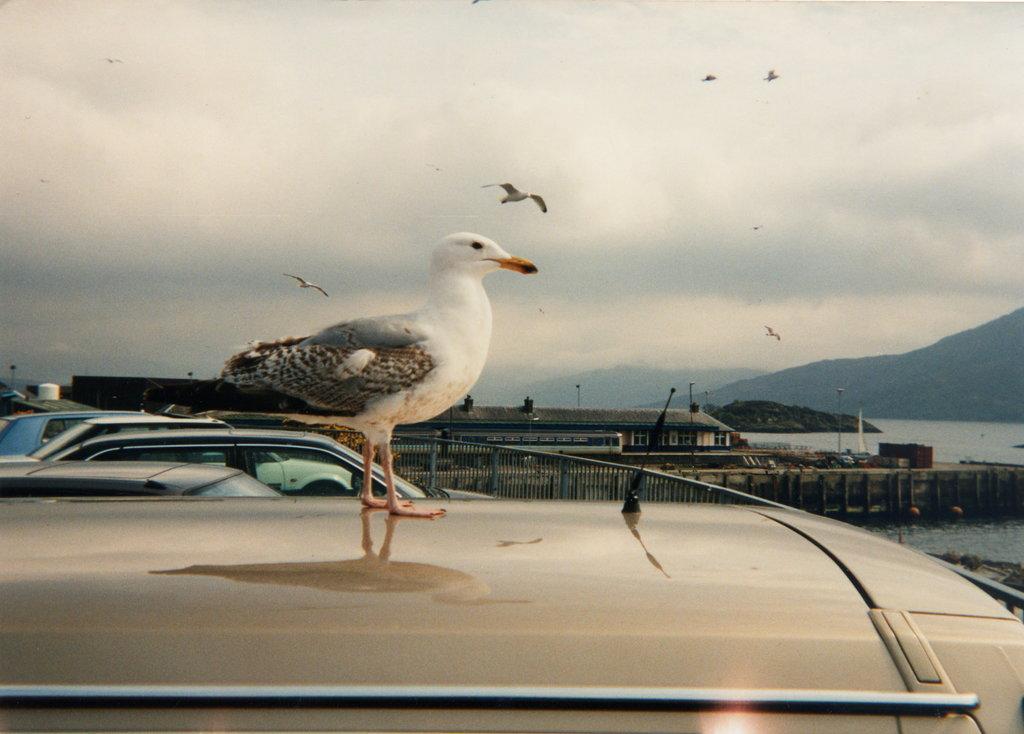How would you summarize this image in a sentence or two? This is an outside view. Here I can see few cars. In the middle of the image there is a bird on a vehicle. In the background there are few buildings. On the right side, I can see the water and a hill. At the top of the image I can see the sky and also there are many birds flying in the air. 